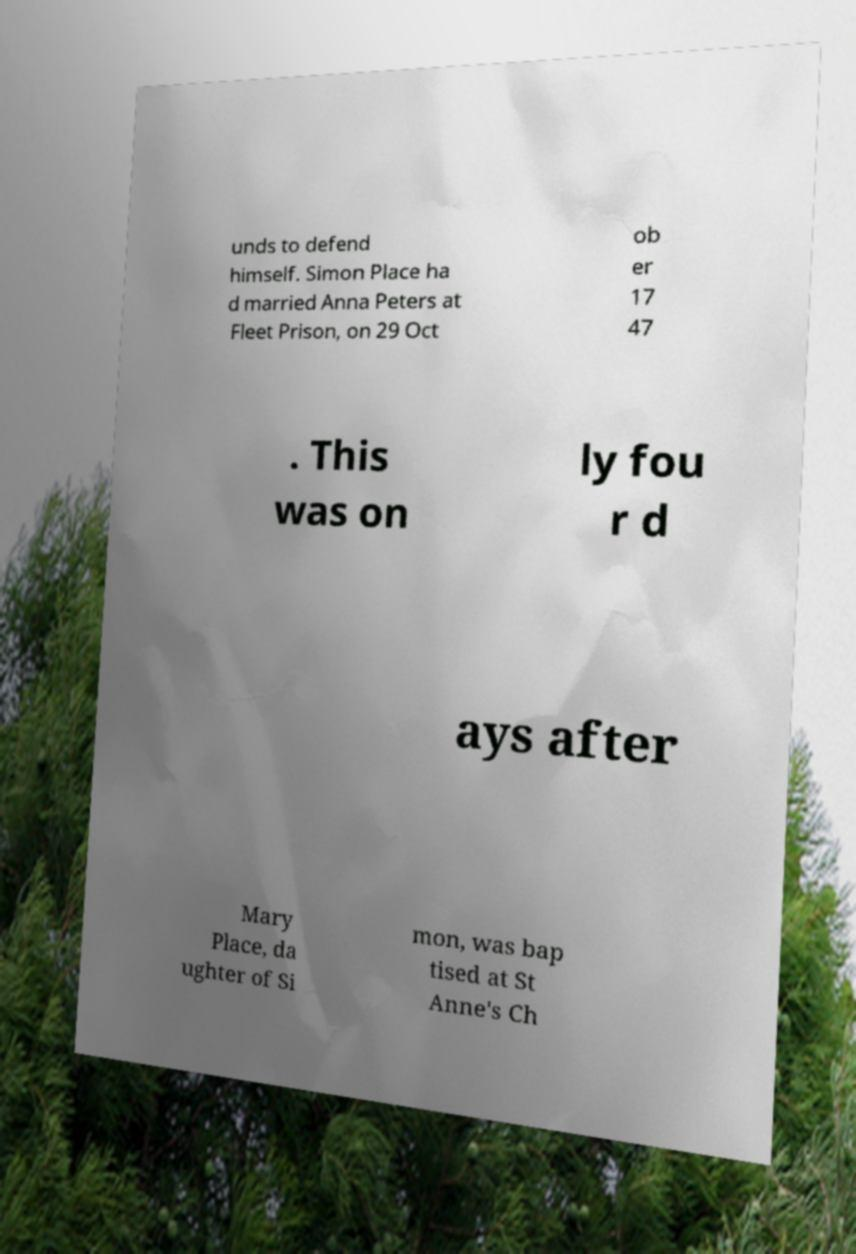Could you extract and type out the text from this image? unds to defend himself. Simon Place ha d married Anna Peters at Fleet Prison, on 29 Oct ob er 17 47 . This was on ly fou r d ays after Mary Place, da ughter of Si mon, was bap tised at St Anne's Ch 